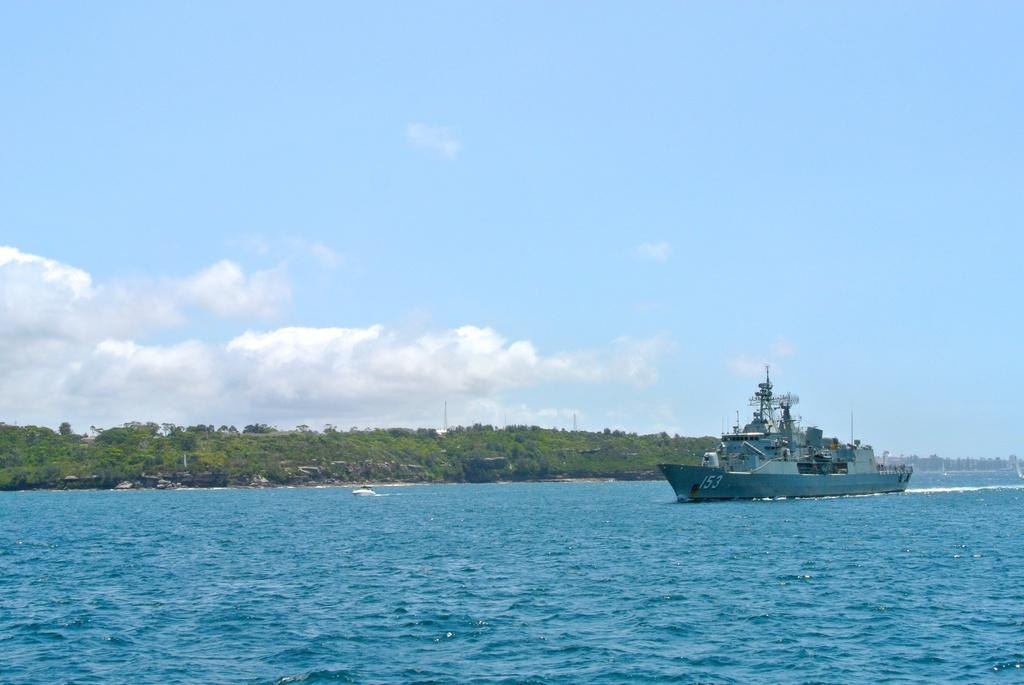What is the main subject of the image? The main subject of the image is a ship on the water. Where is the ship located in the image? The ship is on the right side of the image. What can be seen in the background of the image? There are trees in the background of the image. What is visible at the top of the image? The sky is visible at the top of the image. What type of boot is visible on the ship in the image? There is no boot present on the ship in the image. What shape is the ship in the image? The shape of the ship cannot be determined from the image alone, as it only provides a partial view of the ship. 